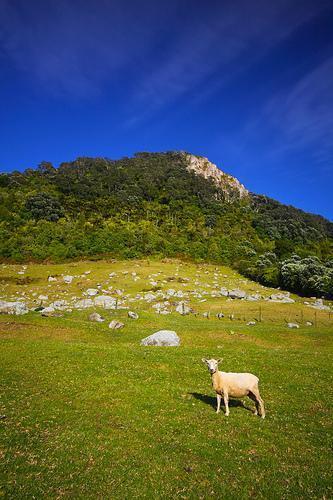How many sheep are there?
Give a very brief answer. 1. How many sheeps are eating food?
Give a very brief answer. 0. 